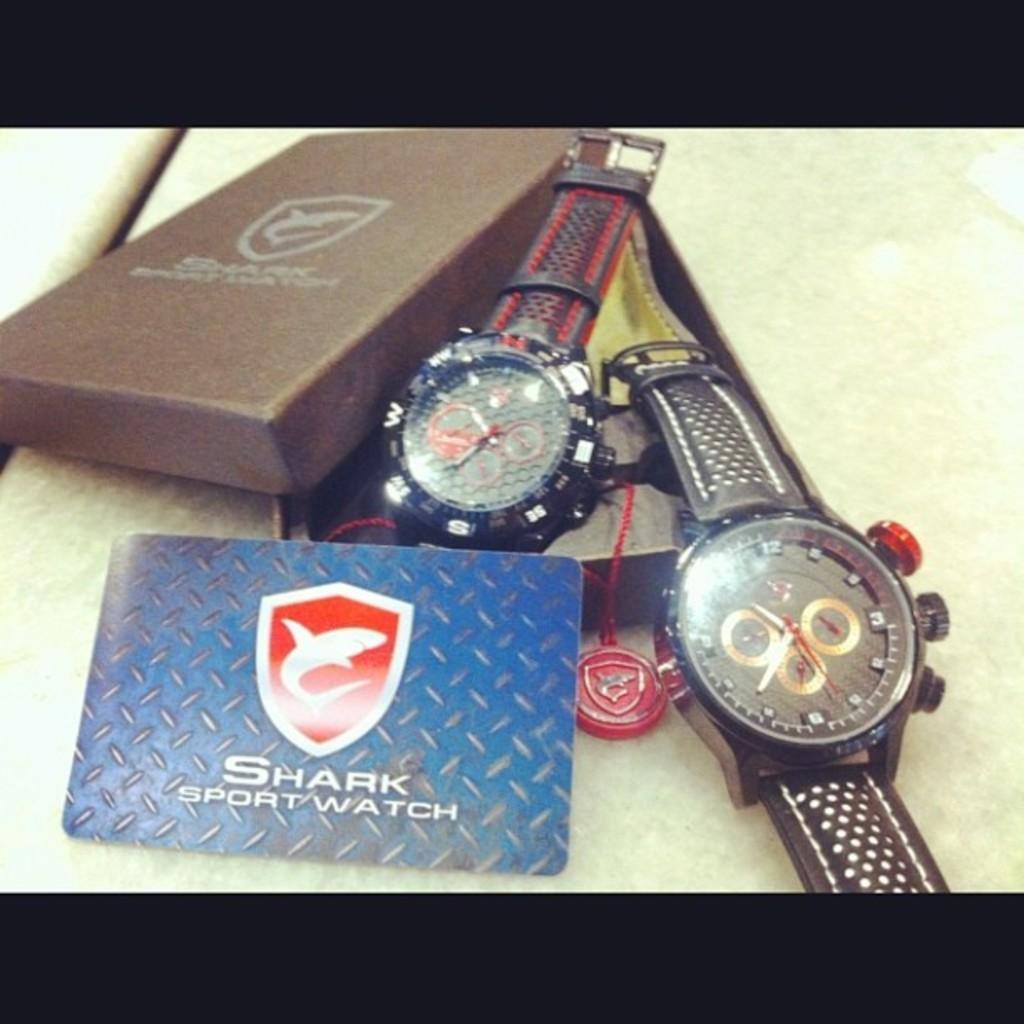<image>
Write a terse but informative summary of the picture. Two watches and a card reading Shark Sport Watch. 